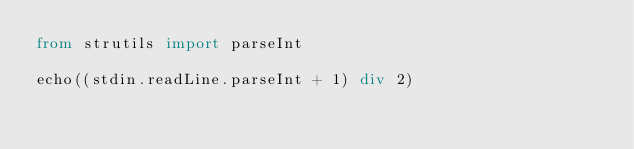Convert code to text. <code><loc_0><loc_0><loc_500><loc_500><_Nim_>from strutils import parseInt

echo((stdin.readLine.parseInt + 1) div 2)
</code> 